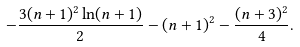Convert formula to latex. <formula><loc_0><loc_0><loc_500><loc_500>- \frac { 3 ( n + 1 ) ^ { 2 } \ln ( n + 1 ) } 2 - ( n + 1 ) ^ { 2 } - \frac { ( n + 3 ) ^ { 2 } } 4 .</formula> 